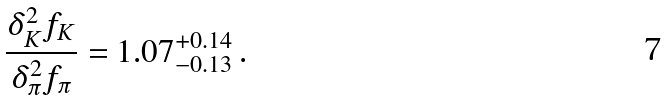<formula> <loc_0><loc_0><loc_500><loc_500>\frac { \delta _ { K } ^ { 2 } f _ { K } } { \delta _ { \pi } ^ { 2 } f _ { \pi } } = 1 . 0 7 ^ { + 0 . 1 4 } _ { - 0 . 1 3 } \, .</formula> 